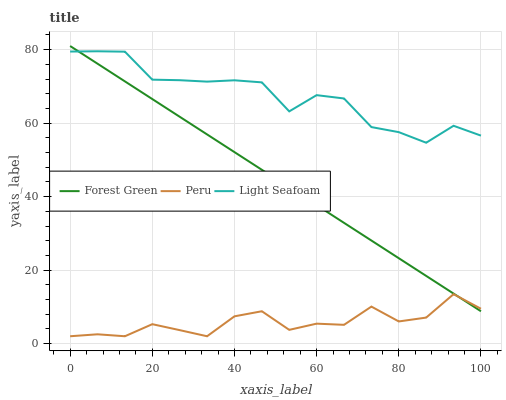Does Light Seafoam have the minimum area under the curve?
Answer yes or no. No. Does Peru have the maximum area under the curve?
Answer yes or no. No. Is Peru the smoothest?
Answer yes or no. No. Is Peru the roughest?
Answer yes or no. No. Does Light Seafoam have the lowest value?
Answer yes or no. No. Does Light Seafoam have the highest value?
Answer yes or no. No. Is Peru less than Light Seafoam?
Answer yes or no. Yes. Is Light Seafoam greater than Peru?
Answer yes or no. Yes. Does Peru intersect Light Seafoam?
Answer yes or no. No. 